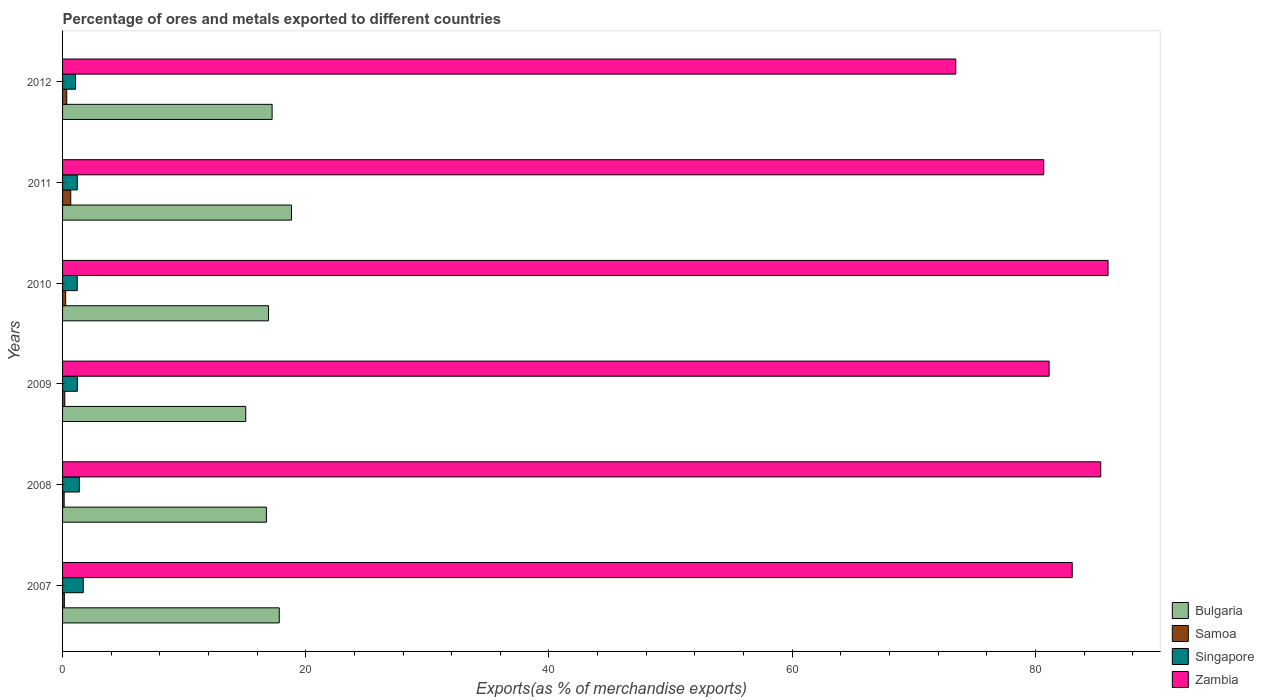How many different coloured bars are there?
Provide a succinct answer. 4. Are the number of bars on each tick of the Y-axis equal?
Keep it short and to the point. Yes. How many bars are there on the 4th tick from the bottom?
Provide a short and direct response. 4. What is the label of the 3rd group of bars from the top?
Your answer should be very brief. 2010. In how many cases, is the number of bars for a given year not equal to the number of legend labels?
Make the answer very short. 0. What is the percentage of exports to different countries in Bulgaria in 2011?
Give a very brief answer. 18.82. Across all years, what is the maximum percentage of exports to different countries in Samoa?
Offer a terse response. 0.67. Across all years, what is the minimum percentage of exports to different countries in Singapore?
Ensure brevity in your answer.  1.07. In which year was the percentage of exports to different countries in Zambia minimum?
Give a very brief answer. 2012. What is the total percentage of exports to different countries in Samoa in the graph?
Provide a short and direct response. 1.73. What is the difference between the percentage of exports to different countries in Singapore in 2008 and that in 2009?
Provide a succinct answer. 0.17. What is the difference between the percentage of exports to different countries in Singapore in 2008 and the percentage of exports to different countries in Zambia in 2007?
Your answer should be very brief. -81.65. What is the average percentage of exports to different countries in Singapore per year?
Provide a short and direct response. 1.3. In the year 2008, what is the difference between the percentage of exports to different countries in Samoa and percentage of exports to different countries in Bulgaria?
Make the answer very short. -16.63. What is the ratio of the percentage of exports to different countries in Bulgaria in 2007 to that in 2008?
Keep it short and to the point. 1.06. What is the difference between the highest and the second highest percentage of exports to different countries in Zambia?
Make the answer very short. 0.6. What is the difference between the highest and the lowest percentage of exports to different countries in Samoa?
Offer a very short reply. 0.54. Is the sum of the percentage of exports to different countries in Samoa in 2007 and 2010 greater than the maximum percentage of exports to different countries in Bulgaria across all years?
Make the answer very short. No. Is it the case that in every year, the sum of the percentage of exports to different countries in Singapore and percentage of exports to different countries in Zambia is greater than the sum of percentage of exports to different countries in Bulgaria and percentage of exports to different countries in Samoa?
Provide a succinct answer. Yes. What does the 2nd bar from the top in 2007 represents?
Provide a succinct answer. Singapore. Is it the case that in every year, the sum of the percentage of exports to different countries in Singapore and percentage of exports to different countries in Bulgaria is greater than the percentage of exports to different countries in Samoa?
Keep it short and to the point. Yes. How many years are there in the graph?
Your answer should be very brief. 6. Does the graph contain any zero values?
Provide a short and direct response. No. How many legend labels are there?
Offer a very short reply. 4. What is the title of the graph?
Offer a very short reply. Percentage of ores and metals exported to different countries. Does "Malta" appear as one of the legend labels in the graph?
Offer a very short reply. No. What is the label or title of the X-axis?
Your answer should be compact. Exports(as % of merchandise exports). What is the Exports(as % of merchandise exports) in Bulgaria in 2007?
Ensure brevity in your answer.  17.82. What is the Exports(as % of merchandise exports) of Samoa in 2007?
Make the answer very short. 0.15. What is the Exports(as % of merchandise exports) of Singapore in 2007?
Your answer should be compact. 1.7. What is the Exports(as % of merchandise exports) in Zambia in 2007?
Offer a terse response. 83.03. What is the Exports(as % of merchandise exports) of Bulgaria in 2008?
Offer a very short reply. 16.76. What is the Exports(as % of merchandise exports) in Samoa in 2008?
Ensure brevity in your answer.  0.13. What is the Exports(as % of merchandise exports) in Singapore in 2008?
Your answer should be very brief. 1.38. What is the Exports(as % of merchandise exports) of Zambia in 2008?
Ensure brevity in your answer.  85.37. What is the Exports(as % of merchandise exports) in Bulgaria in 2009?
Give a very brief answer. 15.06. What is the Exports(as % of merchandise exports) of Samoa in 2009?
Ensure brevity in your answer.  0.18. What is the Exports(as % of merchandise exports) of Singapore in 2009?
Provide a succinct answer. 1.22. What is the Exports(as % of merchandise exports) in Zambia in 2009?
Ensure brevity in your answer.  81.13. What is the Exports(as % of merchandise exports) of Bulgaria in 2010?
Keep it short and to the point. 16.93. What is the Exports(as % of merchandise exports) in Samoa in 2010?
Provide a short and direct response. 0.25. What is the Exports(as % of merchandise exports) in Singapore in 2010?
Ensure brevity in your answer.  1.21. What is the Exports(as % of merchandise exports) of Zambia in 2010?
Offer a terse response. 85.97. What is the Exports(as % of merchandise exports) in Bulgaria in 2011?
Offer a very short reply. 18.82. What is the Exports(as % of merchandise exports) in Samoa in 2011?
Offer a very short reply. 0.67. What is the Exports(as % of merchandise exports) in Singapore in 2011?
Provide a succinct answer. 1.21. What is the Exports(as % of merchandise exports) in Zambia in 2011?
Ensure brevity in your answer.  80.68. What is the Exports(as % of merchandise exports) of Bulgaria in 2012?
Your response must be concise. 17.23. What is the Exports(as % of merchandise exports) in Samoa in 2012?
Provide a succinct answer. 0.34. What is the Exports(as % of merchandise exports) in Singapore in 2012?
Your answer should be very brief. 1.07. What is the Exports(as % of merchandise exports) in Zambia in 2012?
Your answer should be compact. 73.45. Across all years, what is the maximum Exports(as % of merchandise exports) in Bulgaria?
Keep it short and to the point. 18.82. Across all years, what is the maximum Exports(as % of merchandise exports) of Samoa?
Your response must be concise. 0.67. Across all years, what is the maximum Exports(as % of merchandise exports) in Singapore?
Provide a succinct answer. 1.7. Across all years, what is the maximum Exports(as % of merchandise exports) in Zambia?
Provide a short and direct response. 85.97. Across all years, what is the minimum Exports(as % of merchandise exports) in Bulgaria?
Offer a terse response. 15.06. Across all years, what is the minimum Exports(as % of merchandise exports) in Samoa?
Your answer should be compact. 0.13. Across all years, what is the minimum Exports(as % of merchandise exports) of Singapore?
Provide a succinct answer. 1.07. Across all years, what is the minimum Exports(as % of merchandise exports) in Zambia?
Provide a short and direct response. 73.45. What is the total Exports(as % of merchandise exports) in Bulgaria in the graph?
Make the answer very short. 102.63. What is the total Exports(as % of merchandise exports) in Samoa in the graph?
Offer a terse response. 1.73. What is the total Exports(as % of merchandise exports) of Singapore in the graph?
Make the answer very short. 7.78. What is the total Exports(as % of merchandise exports) in Zambia in the graph?
Give a very brief answer. 489.63. What is the difference between the Exports(as % of merchandise exports) in Bulgaria in 2007 and that in 2008?
Your answer should be very brief. 1.06. What is the difference between the Exports(as % of merchandise exports) of Samoa in 2007 and that in 2008?
Offer a very short reply. 0.02. What is the difference between the Exports(as % of merchandise exports) of Singapore in 2007 and that in 2008?
Your answer should be very brief. 0.32. What is the difference between the Exports(as % of merchandise exports) in Zambia in 2007 and that in 2008?
Your response must be concise. -2.34. What is the difference between the Exports(as % of merchandise exports) in Bulgaria in 2007 and that in 2009?
Give a very brief answer. 2.76. What is the difference between the Exports(as % of merchandise exports) in Samoa in 2007 and that in 2009?
Your answer should be very brief. -0.04. What is the difference between the Exports(as % of merchandise exports) of Singapore in 2007 and that in 2009?
Ensure brevity in your answer.  0.48. What is the difference between the Exports(as % of merchandise exports) of Zambia in 2007 and that in 2009?
Your response must be concise. 1.9. What is the difference between the Exports(as % of merchandise exports) in Bulgaria in 2007 and that in 2010?
Provide a short and direct response. 0.88. What is the difference between the Exports(as % of merchandise exports) in Samoa in 2007 and that in 2010?
Give a very brief answer. -0.11. What is the difference between the Exports(as % of merchandise exports) in Singapore in 2007 and that in 2010?
Provide a succinct answer. 0.49. What is the difference between the Exports(as % of merchandise exports) in Zambia in 2007 and that in 2010?
Offer a very short reply. -2.95. What is the difference between the Exports(as % of merchandise exports) in Bulgaria in 2007 and that in 2011?
Offer a terse response. -1. What is the difference between the Exports(as % of merchandise exports) in Samoa in 2007 and that in 2011?
Your answer should be very brief. -0.53. What is the difference between the Exports(as % of merchandise exports) in Singapore in 2007 and that in 2011?
Your answer should be compact. 0.49. What is the difference between the Exports(as % of merchandise exports) in Zambia in 2007 and that in 2011?
Provide a short and direct response. 2.34. What is the difference between the Exports(as % of merchandise exports) of Bulgaria in 2007 and that in 2012?
Your answer should be compact. 0.59. What is the difference between the Exports(as % of merchandise exports) in Samoa in 2007 and that in 2012?
Your answer should be very brief. -0.19. What is the difference between the Exports(as % of merchandise exports) of Singapore in 2007 and that in 2012?
Keep it short and to the point. 0.63. What is the difference between the Exports(as % of merchandise exports) in Zambia in 2007 and that in 2012?
Offer a terse response. 9.58. What is the difference between the Exports(as % of merchandise exports) of Bulgaria in 2008 and that in 2009?
Make the answer very short. 1.7. What is the difference between the Exports(as % of merchandise exports) of Samoa in 2008 and that in 2009?
Keep it short and to the point. -0.05. What is the difference between the Exports(as % of merchandise exports) in Singapore in 2008 and that in 2009?
Offer a terse response. 0.17. What is the difference between the Exports(as % of merchandise exports) in Zambia in 2008 and that in 2009?
Keep it short and to the point. 4.25. What is the difference between the Exports(as % of merchandise exports) in Bulgaria in 2008 and that in 2010?
Keep it short and to the point. -0.17. What is the difference between the Exports(as % of merchandise exports) of Samoa in 2008 and that in 2010?
Provide a short and direct response. -0.12. What is the difference between the Exports(as % of merchandise exports) in Singapore in 2008 and that in 2010?
Offer a very short reply. 0.18. What is the difference between the Exports(as % of merchandise exports) in Zambia in 2008 and that in 2010?
Your answer should be compact. -0.6. What is the difference between the Exports(as % of merchandise exports) in Bulgaria in 2008 and that in 2011?
Make the answer very short. -2.06. What is the difference between the Exports(as % of merchandise exports) of Samoa in 2008 and that in 2011?
Give a very brief answer. -0.54. What is the difference between the Exports(as % of merchandise exports) of Singapore in 2008 and that in 2011?
Keep it short and to the point. 0.17. What is the difference between the Exports(as % of merchandise exports) of Zambia in 2008 and that in 2011?
Make the answer very short. 4.69. What is the difference between the Exports(as % of merchandise exports) of Bulgaria in 2008 and that in 2012?
Keep it short and to the point. -0.47. What is the difference between the Exports(as % of merchandise exports) in Samoa in 2008 and that in 2012?
Provide a succinct answer. -0.21. What is the difference between the Exports(as % of merchandise exports) of Singapore in 2008 and that in 2012?
Provide a short and direct response. 0.31. What is the difference between the Exports(as % of merchandise exports) in Zambia in 2008 and that in 2012?
Provide a succinct answer. 11.92. What is the difference between the Exports(as % of merchandise exports) in Bulgaria in 2009 and that in 2010?
Provide a succinct answer. -1.87. What is the difference between the Exports(as % of merchandise exports) of Samoa in 2009 and that in 2010?
Your answer should be compact. -0.07. What is the difference between the Exports(as % of merchandise exports) of Singapore in 2009 and that in 2010?
Your answer should be compact. 0.01. What is the difference between the Exports(as % of merchandise exports) in Zambia in 2009 and that in 2010?
Make the answer very short. -4.85. What is the difference between the Exports(as % of merchandise exports) of Bulgaria in 2009 and that in 2011?
Your answer should be compact. -3.76. What is the difference between the Exports(as % of merchandise exports) of Samoa in 2009 and that in 2011?
Provide a succinct answer. -0.49. What is the difference between the Exports(as % of merchandise exports) of Singapore in 2009 and that in 2011?
Provide a succinct answer. 0. What is the difference between the Exports(as % of merchandise exports) of Zambia in 2009 and that in 2011?
Ensure brevity in your answer.  0.44. What is the difference between the Exports(as % of merchandise exports) of Bulgaria in 2009 and that in 2012?
Your response must be concise. -2.17. What is the difference between the Exports(as % of merchandise exports) of Samoa in 2009 and that in 2012?
Offer a terse response. -0.16. What is the difference between the Exports(as % of merchandise exports) of Singapore in 2009 and that in 2012?
Offer a very short reply. 0.15. What is the difference between the Exports(as % of merchandise exports) of Zambia in 2009 and that in 2012?
Provide a short and direct response. 7.67. What is the difference between the Exports(as % of merchandise exports) in Bulgaria in 2010 and that in 2011?
Offer a terse response. -1.89. What is the difference between the Exports(as % of merchandise exports) in Samoa in 2010 and that in 2011?
Your response must be concise. -0.42. What is the difference between the Exports(as % of merchandise exports) in Singapore in 2010 and that in 2011?
Offer a very short reply. -0.01. What is the difference between the Exports(as % of merchandise exports) in Zambia in 2010 and that in 2011?
Your answer should be compact. 5.29. What is the difference between the Exports(as % of merchandise exports) in Bulgaria in 2010 and that in 2012?
Keep it short and to the point. -0.3. What is the difference between the Exports(as % of merchandise exports) of Samoa in 2010 and that in 2012?
Provide a succinct answer. -0.09. What is the difference between the Exports(as % of merchandise exports) of Singapore in 2010 and that in 2012?
Ensure brevity in your answer.  0.14. What is the difference between the Exports(as % of merchandise exports) in Zambia in 2010 and that in 2012?
Give a very brief answer. 12.52. What is the difference between the Exports(as % of merchandise exports) of Bulgaria in 2011 and that in 2012?
Offer a terse response. 1.59. What is the difference between the Exports(as % of merchandise exports) in Samoa in 2011 and that in 2012?
Your answer should be compact. 0.33. What is the difference between the Exports(as % of merchandise exports) in Singapore in 2011 and that in 2012?
Your answer should be very brief. 0.14. What is the difference between the Exports(as % of merchandise exports) of Zambia in 2011 and that in 2012?
Offer a very short reply. 7.23. What is the difference between the Exports(as % of merchandise exports) in Bulgaria in 2007 and the Exports(as % of merchandise exports) in Samoa in 2008?
Your response must be concise. 17.69. What is the difference between the Exports(as % of merchandise exports) of Bulgaria in 2007 and the Exports(as % of merchandise exports) of Singapore in 2008?
Make the answer very short. 16.44. What is the difference between the Exports(as % of merchandise exports) in Bulgaria in 2007 and the Exports(as % of merchandise exports) in Zambia in 2008?
Your answer should be very brief. -67.55. What is the difference between the Exports(as % of merchandise exports) of Samoa in 2007 and the Exports(as % of merchandise exports) of Singapore in 2008?
Give a very brief answer. -1.23. What is the difference between the Exports(as % of merchandise exports) of Samoa in 2007 and the Exports(as % of merchandise exports) of Zambia in 2008?
Provide a short and direct response. -85.22. What is the difference between the Exports(as % of merchandise exports) in Singapore in 2007 and the Exports(as % of merchandise exports) in Zambia in 2008?
Ensure brevity in your answer.  -83.67. What is the difference between the Exports(as % of merchandise exports) of Bulgaria in 2007 and the Exports(as % of merchandise exports) of Samoa in 2009?
Keep it short and to the point. 17.64. What is the difference between the Exports(as % of merchandise exports) of Bulgaria in 2007 and the Exports(as % of merchandise exports) of Singapore in 2009?
Provide a short and direct response. 16.6. What is the difference between the Exports(as % of merchandise exports) in Bulgaria in 2007 and the Exports(as % of merchandise exports) in Zambia in 2009?
Ensure brevity in your answer.  -63.31. What is the difference between the Exports(as % of merchandise exports) in Samoa in 2007 and the Exports(as % of merchandise exports) in Singapore in 2009?
Provide a succinct answer. -1.07. What is the difference between the Exports(as % of merchandise exports) in Samoa in 2007 and the Exports(as % of merchandise exports) in Zambia in 2009?
Keep it short and to the point. -80.98. What is the difference between the Exports(as % of merchandise exports) in Singapore in 2007 and the Exports(as % of merchandise exports) in Zambia in 2009?
Your answer should be compact. -79.43. What is the difference between the Exports(as % of merchandise exports) in Bulgaria in 2007 and the Exports(as % of merchandise exports) in Samoa in 2010?
Keep it short and to the point. 17.56. What is the difference between the Exports(as % of merchandise exports) of Bulgaria in 2007 and the Exports(as % of merchandise exports) of Singapore in 2010?
Provide a short and direct response. 16.61. What is the difference between the Exports(as % of merchandise exports) of Bulgaria in 2007 and the Exports(as % of merchandise exports) of Zambia in 2010?
Give a very brief answer. -68.15. What is the difference between the Exports(as % of merchandise exports) of Samoa in 2007 and the Exports(as % of merchandise exports) of Singapore in 2010?
Your answer should be very brief. -1.06. What is the difference between the Exports(as % of merchandise exports) in Samoa in 2007 and the Exports(as % of merchandise exports) in Zambia in 2010?
Offer a terse response. -85.83. What is the difference between the Exports(as % of merchandise exports) in Singapore in 2007 and the Exports(as % of merchandise exports) in Zambia in 2010?
Give a very brief answer. -84.27. What is the difference between the Exports(as % of merchandise exports) in Bulgaria in 2007 and the Exports(as % of merchandise exports) in Samoa in 2011?
Provide a succinct answer. 17.15. What is the difference between the Exports(as % of merchandise exports) in Bulgaria in 2007 and the Exports(as % of merchandise exports) in Singapore in 2011?
Provide a short and direct response. 16.61. What is the difference between the Exports(as % of merchandise exports) of Bulgaria in 2007 and the Exports(as % of merchandise exports) of Zambia in 2011?
Provide a short and direct response. -62.86. What is the difference between the Exports(as % of merchandise exports) of Samoa in 2007 and the Exports(as % of merchandise exports) of Singapore in 2011?
Your response must be concise. -1.06. What is the difference between the Exports(as % of merchandise exports) of Samoa in 2007 and the Exports(as % of merchandise exports) of Zambia in 2011?
Give a very brief answer. -80.54. What is the difference between the Exports(as % of merchandise exports) of Singapore in 2007 and the Exports(as % of merchandise exports) of Zambia in 2011?
Make the answer very short. -78.98. What is the difference between the Exports(as % of merchandise exports) in Bulgaria in 2007 and the Exports(as % of merchandise exports) in Samoa in 2012?
Provide a short and direct response. 17.48. What is the difference between the Exports(as % of merchandise exports) in Bulgaria in 2007 and the Exports(as % of merchandise exports) in Singapore in 2012?
Offer a very short reply. 16.75. What is the difference between the Exports(as % of merchandise exports) of Bulgaria in 2007 and the Exports(as % of merchandise exports) of Zambia in 2012?
Your answer should be very brief. -55.63. What is the difference between the Exports(as % of merchandise exports) in Samoa in 2007 and the Exports(as % of merchandise exports) in Singapore in 2012?
Give a very brief answer. -0.92. What is the difference between the Exports(as % of merchandise exports) in Samoa in 2007 and the Exports(as % of merchandise exports) in Zambia in 2012?
Offer a very short reply. -73.3. What is the difference between the Exports(as % of merchandise exports) in Singapore in 2007 and the Exports(as % of merchandise exports) in Zambia in 2012?
Provide a short and direct response. -71.75. What is the difference between the Exports(as % of merchandise exports) in Bulgaria in 2008 and the Exports(as % of merchandise exports) in Samoa in 2009?
Your answer should be compact. 16.58. What is the difference between the Exports(as % of merchandise exports) of Bulgaria in 2008 and the Exports(as % of merchandise exports) of Singapore in 2009?
Your answer should be very brief. 15.54. What is the difference between the Exports(as % of merchandise exports) in Bulgaria in 2008 and the Exports(as % of merchandise exports) in Zambia in 2009?
Keep it short and to the point. -64.37. What is the difference between the Exports(as % of merchandise exports) of Samoa in 2008 and the Exports(as % of merchandise exports) of Singapore in 2009?
Make the answer very short. -1.08. What is the difference between the Exports(as % of merchandise exports) of Samoa in 2008 and the Exports(as % of merchandise exports) of Zambia in 2009?
Provide a short and direct response. -81. What is the difference between the Exports(as % of merchandise exports) in Singapore in 2008 and the Exports(as % of merchandise exports) in Zambia in 2009?
Make the answer very short. -79.75. What is the difference between the Exports(as % of merchandise exports) in Bulgaria in 2008 and the Exports(as % of merchandise exports) in Samoa in 2010?
Your response must be concise. 16.51. What is the difference between the Exports(as % of merchandise exports) in Bulgaria in 2008 and the Exports(as % of merchandise exports) in Singapore in 2010?
Make the answer very short. 15.55. What is the difference between the Exports(as % of merchandise exports) in Bulgaria in 2008 and the Exports(as % of merchandise exports) in Zambia in 2010?
Ensure brevity in your answer.  -69.21. What is the difference between the Exports(as % of merchandise exports) of Samoa in 2008 and the Exports(as % of merchandise exports) of Singapore in 2010?
Your answer should be compact. -1.08. What is the difference between the Exports(as % of merchandise exports) of Samoa in 2008 and the Exports(as % of merchandise exports) of Zambia in 2010?
Your answer should be very brief. -85.84. What is the difference between the Exports(as % of merchandise exports) in Singapore in 2008 and the Exports(as % of merchandise exports) in Zambia in 2010?
Keep it short and to the point. -84.59. What is the difference between the Exports(as % of merchandise exports) of Bulgaria in 2008 and the Exports(as % of merchandise exports) of Samoa in 2011?
Ensure brevity in your answer.  16.09. What is the difference between the Exports(as % of merchandise exports) in Bulgaria in 2008 and the Exports(as % of merchandise exports) in Singapore in 2011?
Provide a short and direct response. 15.55. What is the difference between the Exports(as % of merchandise exports) of Bulgaria in 2008 and the Exports(as % of merchandise exports) of Zambia in 2011?
Provide a short and direct response. -63.92. What is the difference between the Exports(as % of merchandise exports) of Samoa in 2008 and the Exports(as % of merchandise exports) of Singapore in 2011?
Ensure brevity in your answer.  -1.08. What is the difference between the Exports(as % of merchandise exports) of Samoa in 2008 and the Exports(as % of merchandise exports) of Zambia in 2011?
Make the answer very short. -80.55. What is the difference between the Exports(as % of merchandise exports) in Singapore in 2008 and the Exports(as % of merchandise exports) in Zambia in 2011?
Ensure brevity in your answer.  -79.3. What is the difference between the Exports(as % of merchandise exports) in Bulgaria in 2008 and the Exports(as % of merchandise exports) in Samoa in 2012?
Offer a terse response. 16.42. What is the difference between the Exports(as % of merchandise exports) in Bulgaria in 2008 and the Exports(as % of merchandise exports) in Singapore in 2012?
Keep it short and to the point. 15.69. What is the difference between the Exports(as % of merchandise exports) of Bulgaria in 2008 and the Exports(as % of merchandise exports) of Zambia in 2012?
Offer a terse response. -56.69. What is the difference between the Exports(as % of merchandise exports) in Samoa in 2008 and the Exports(as % of merchandise exports) in Singapore in 2012?
Provide a succinct answer. -0.94. What is the difference between the Exports(as % of merchandise exports) in Samoa in 2008 and the Exports(as % of merchandise exports) in Zambia in 2012?
Keep it short and to the point. -73.32. What is the difference between the Exports(as % of merchandise exports) in Singapore in 2008 and the Exports(as % of merchandise exports) in Zambia in 2012?
Your response must be concise. -72.07. What is the difference between the Exports(as % of merchandise exports) in Bulgaria in 2009 and the Exports(as % of merchandise exports) in Samoa in 2010?
Provide a succinct answer. 14.81. What is the difference between the Exports(as % of merchandise exports) of Bulgaria in 2009 and the Exports(as % of merchandise exports) of Singapore in 2010?
Your answer should be compact. 13.86. What is the difference between the Exports(as % of merchandise exports) in Bulgaria in 2009 and the Exports(as % of merchandise exports) in Zambia in 2010?
Keep it short and to the point. -70.91. What is the difference between the Exports(as % of merchandise exports) in Samoa in 2009 and the Exports(as % of merchandise exports) in Singapore in 2010?
Your answer should be compact. -1.02. What is the difference between the Exports(as % of merchandise exports) of Samoa in 2009 and the Exports(as % of merchandise exports) of Zambia in 2010?
Provide a short and direct response. -85.79. What is the difference between the Exports(as % of merchandise exports) of Singapore in 2009 and the Exports(as % of merchandise exports) of Zambia in 2010?
Offer a terse response. -84.76. What is the difference between the Exports(as % of merchandise exports) in Bulgaria in 2009 and the Exports(as % of merchandise exports) in Samoa in 2011?
Your answer should be compact. 14.39. What is the difference between the Exports(as % of merchandise exports) of Bulgaria in 2009 and the Exports(as % of merchandise exports) of Singapore in 2011?
Give a very brief answer. 13.85. What is the difference between the Exports(as % of merchandise exports) in Bulgaria in 2009 and the Exports(as % of merchandise exports) in Zambia in 2011?
Your answer should be compact. -65.62. What is the difference between the Exports(as % of merchandise exports) of Samoa in 2009 and the Exports(as % of merchandise exports) of Singapore in 2011?
Give a very brief answer. -1.03. What is the difference between the Exports(as % of merchandise exports) of Samoa in 2009 and the Exports(as % of merchandise exports) of Zambia in 2011?
Your answer should be compact. -80.5. What is the difference between the Exports(as % of merchandise exports) in Singapore in 2009 and the Exports(as % of merchandise exports) in Zambia in 2011?
Offer a terse response. -79.47. What is the difference between the Exports(as % of merchandise exports) of Bulgaria in 2009 and the Exports(as % of merchandise exports) of Samoa in 2012?
Offer a very short reply. 14.72. What is the difference between the Exports(as % of merchandise exports) of Bulgaria in 2009 and the Exports(as % of merchandise exports) of Singapore in 2012?
Offer a very short reply. 13.99. What is the difference between the Exports(as % of merchandise exports) of Bulgaria in 2009 and the Exports(as % of merchandise exports) of Zambia in 2012?
Offer a very short reply. -58.39. What is the difference between the Exports(as % of merchandise exports) of Samoa in 2009 and the Exports(as % of merchandise exports) of Singapore in 2012?
Make the answer very short. -0.88. What is the difference between the Exports(as % of merchandise exports) of Samoa in 2009 and the Exports(as % of merchandise exports) of Zambia in 2012?
Keep it short and to the point. -73.27. What is the difference between the Exports(as % of merchandise exports) in Singapore in 2009 and the Exports(as % of merchandise exports) in Zambia in 2012?
Your answer should be very brief. -72.24. What is the difference between the Exports(as % of merchandise exports) in Bulgaria in 2010 and the Exports(as % of merchandise exports) in Samoa in 2011?
Provide a short and direct response. 16.26. What is the difference between the Exports(as % of merchandise exports) of Bulgaria in 2010 and the Exports(as % of merchandise exports) of Singapore in 2011?
Offer a very short reply. 15.72. What is the difference between the Exports(as % of merchandise exports) of Bulgaria in 2010 and the Exports(as % of merchandise exports) of Zambia in 2011?
Your answer should be compact. -63.75. What is the difference between the Exports(as % of merchandise exports) in Samoa in 2010 and the Exports(as % of merchandise exports) in Singapore in 2011?
Offer a very short reply. -0.96. What is the difference between the Exports(as % of merchandise exports) in Samoa in 2010 and the Exports(as % of merchandise exports) in Zambia in 2011?
Make the answer very short. -80.43. What is the difference between the Exports(as % of merchandise exports) of Singapore in 2010 and the Exports(as % of merchandise exports) of Zambia in 2011?
Keep it short and to the point. -79.48. What is the difference between the Exports(as % of merchandise exports) of Bulgaria in 2010 and the Exports(as % of merchandise exports) of Samoa in 2012?
Your answer should be compact. 16.59. What is the difference between the Exports(as % of merchandise exports) of Bulgaria in 2010 and the Exports(as % of merchandise exports) of Singapore in 2012?
Keep it short and to the point. 15.87. What is the difference between the Exports(as % of merchandise exports) of Bulgaria in 2010 and the Exports(as % of merchandise exports) of Zambia in 2012?
Offer a very short reply. -56.52. What is the difference between the Exports(as % of merchandise exports) of Samoa in 2010 and the Exports(as % of merchandise exports) of Singapore in 2012?
Keep it short and to the point. -0.81. What is the difference between the Exports(as % of merchandise exports) of Samoa in 2010 and the Exports(as % of merchandise exports) of Zambia in 2012?
Offer a very short reply. -73.2. What is the difference between the Exports(as % of merchandise exports) of Singapore in 2010 and the Exports(as % of merchandise exports) of Zambia in 2012?
Offer a very short reply. -72.25. What is the difference between the Exports(as % of merchandise exports) in Bulgaria in 2011 and the Exports(as % of merchandise exports) in Samoa in 2012?
Provide a short and direct response. 18.48. What is the difference between the Exports(as % of merchandise exports) of Bulgaria in 2011 and the Exports(as % of merchandise exports) of Singapore in 2012?
Make the answer very short. 17.75. What is the difference between the Exports(as % of merchandise exports) in Bulgaria in 2011 and the Exports(as % of merchandise exports) in Zambia in 2012?
Your response must be concise. -54.63. What is the difference between the Exports(as % of merchandise exports) of Samoa in 2011 and the Exports(as % of merchandise exports) of Singapore in 2012?
Keep it short and to the point. -0.39. What is the difference between the Exports(as % of merchandise exports) in Samoa in 2011 and the Exports(as % of merchandise exports) in Zambia in 2012?
Provide a succinct answer. -72.78. What is the difference between the Exports(as % of merchandise exports) of Singapore in 2011 and the Exports(as % of merchandise exports) of Zambia in 2012?
Your answer should be compact. -72.24. What is the average Exports(as % of merchandise exports) in Bulgaria per year?
Offer a terse response. 17.11. What is the average Exports(as % of merchandise exports) of Samoa per year?
Give a very brief answer. 0.29. What is the average Exports(as % of merchandise exports) of Singapore per year?
Offer a very short reply. 1.3. What is the average Exports(as % of merchandise exports) of Zambia per year?
Your answer should be very brief. 81.61. In the year 2007, what is the difference between the Exports(as % of merchandise exports) in Bulgaria and Exports(as % of merchandise exports) in Samoa?
Your answer should be very brief. 17.67. In the year 2007, what is the difference between the Exports(as % of merchandise exports) in Bulgaria and Exports(as % of merchandise exports) in Singapore?
Your answer should be compact. 16.12. In the year 2007, what is the difference between the Exports(as % of merchandise exports) of Bulgaria and Exports(as % of merchandise exports) of Zambia?
Your answer should be very brief. -65.21. In the year 2007, what is the difference between the Exports(as % of merchandise exports) of Samoa and Exports(as % of merchandise exports) of Singapore?
Your answer should be very brief. -1.55. In the year 2007, what is the difference between the Exports(as % of merchandise exports) in Samoa and Exports(as % of merchandise exports) in Zambia?
Make the answer very short. -82.88. In the year 2007, what is the difference between the Exports(as % of merchandise exports) in Singapore and Exports(as % of merchandise exports) in Zambia?
Your response must be concise. -81.33. In the year 2008, what is the difference between the Exports(as % of merchandise exports) of Bulgaria and Exports(as % of merchandise exports) of Samoa?
Make the answer very short. 16.63. In the year 2008, what is the difference between the Exports(as % of merchandise exports) of Bulgaria and Exports(as % of merchandise exports) of Singapore?
Make the answer very short. 15.38. In the year 2008, what is the difference between the Exports(as % of merchandise exports) in Bulgaria and Exports(as % of merchandise exports) in Zambia?
Provide a short and direct response. -68.61. In the year 2008, what is the difference between the Exports(as % of merchandise exports) in Samoa and Exports(as % of merchandise exports) in Singapore?
Your answer should be very brief. -1.25. In the year 2008, what is the difference between the Exports(as % of merchandise exports) in Samoa and Exports(as % of merchandise exports) in Zambia?
Ensure brevity in your answer.  -85.24. In the year 2008, what is the difference between the Exports(as % of merchandise exports) in Singapore and Exports(as % of merchandise exports) in Zambia?
Make the answer very short. -83.99. In the year 2009, what is the difference between the Exports(as % of merchandise exports) of Bulgaria and Exports(as % of merchandise exports) of Samoa?
Make the answer very short. 14.88. In the year 2009, what is the difference between the Exports(as % of merchandise exports) in Bulgaria and Exports(as % of merchandise exports) in Singapore?
Offer a terse response. 13.85. In the year 2009, what is the difference between the Exports(as % of merchandise exports) in Bulgaria and Exports(as % of merchandise exports) in Zambia?
Make the answer very short. -66.06. In the year 2009, what is the difference between the Exports(as % of merchandise exports) of Samoa and Exports(as % of merchandise exports) of Singapore?
Offer a very short reply. -1.03. In the year 2009, what is the difference between the Exports(as % of merchandise exports) in Samoa and Exports(as % of merchandise exports) in Zambia?
Your answer should be compact. -80.94. In the year 2009, what is the difference between the Exports(as % of merchandise exports) of Singapore and Exports(as % of merchandise exports) of Zambia?
Your response must be concise. -79.91. In the year 2010, what is the difference between the Exports(as % of merchandise exports) of Bulgaria and Exports(as % of merchandise exports) of Samoa?
Provide a succinct answer. 16.68. In the year 2010, what is the difference between the Exports(as % of merchandise exports) in Bulgaria and Exports(as % of merchandise exports) in Singapore?
Offer a very short reply. 15.73. In the year 2010, what is the difference between the Exports(as % of merchandise exports) in Bulgaria and Exports(as % of merchandise exports) in Zambia?
Provide a succinct answer. -69.04. In the year 2010, what is the difference between the Exports(as % of merchandise exports) of Samoa and Exports(as % of merchandise exports) of Singapore?
Offer a terse response. -0.95. In the year 2010, what is the difference between the Exports(as % of merchandise exports) of Samoa and Exports(as % of merchandise exports) of Zambia?
Make the answer very short. -85.72. In the year 2010, what is the difference between the Exports(as % of merchandise exports) in Singapore and Exports(as % of merchandise exports) in Zambia?
Offer a very short reply. -84.77. In the year 2011, what is the difference between the Exports(as % of merchandise exports) of Bulgaria and Exports(as % of merchandise exports) of Samoa?
Offer a terse response. 18.15. In the year 2011, what is the difference between the Exports(as % of merchandise exports) in Bulgaria and Exports(as % of merchandise exports) in Singapore?
Your answer should be very brief. 17.61. In the year 2011, what is the difference between the Exports(as % of merchandise exports) of Bulgaria and Exports(as % of merchandise exports) of Zambia?
Provide a short and direct response. -61.86. In the year 2011, what is the difference between the Exports(as % of merchandise exports) in Samoa and Exports(as % of merchandise exports) in Singapore?
Your response must be concise. -0.54. In the year 2011, what is the difference between the Exports(as % of merchandise exports) in Samoa and Exports(as % of merchandise exports) in Zambia?
Your answer should be very brief. -80.01. In the year 2011, what is the difference between the Exports(as % of merchandise exports) in Singapore and Exports(as % of merchandise exports) in Zambia?
Ensure brevity in your answer.  -79.47. In the year 2012, what is the difference between the Exports(as % of merchandise exports) in Bulgaria and Exports(as % of merchandise exports) in Samoa?
Your response must be concise. 16.89. In the year 2012, what is the difference between the Exports(as % of merchandise exports) of Bulgaria and Exports(as % of merchandise exports) of Singapore?
Your answer should be very brief. 16.16. In the year 2012, what is the difference between the Exports(as % of merchandise exports) of Bulgaria and Exports(as % of merchandise exports) of Zambia?
Your answer should be very brief. -56.22. In the year 2012, what is the difference between the Exports(as % of merchandise exports) of Samoa and Exports(as % of merchandise exports) of Singapore?
Make the answer very short. -0.73. In the year 2012, what is the difference between the Exports(as % of merchandise exports) of Samoa and Exports(as % of merchandise exports) of Zambia?
Your answer should be very brief. -73.11. In the year 2012, what is the difference between the Exports(as % of merchandise exports) in Singapore and Exports(as % of merchandise exports) in Zambia?
Your answer should be compact. -72.38. What is the ratio of the Exports(as % of merchandise exports) of Bulgaria in 2007 to that in 2008?
Your answer should be very brief. 1.06. What is the ratio of the Exports(as % of merchandise exports) in Samoa in 2007 to that in 2008?
Offer a very short reply. 1.13. What is the ratio of the Exports(as % of merchandise exports) in Singapore in 2007 to that in 2008?
Your response must be concise. 1.23. What is the ratio of the Exports(as % of merchandise exports) in Zambia in 2007 to that in 2008?
Keep it short and to the point. 0.97. What is the ratio of the Exports(as % of merchandise exports) of Bulgaria in 2007 to that in 2009?
Your answer should be very brief. 1.18. What is the ratio of the Exports(as % of merchandise exports) of Samoa in 2007 to that in 2009?
Offer a terse response. 0.81. What is the ratio of the Exports(as % of merchandise exports) in Singapore in 2007 to that in 2009?
Provide a short and direct response. 1.4. What is the ratio of the Exports(as % of merchandise exports) of Zambia in 2007 to that in 2009?
Your response must be concise. 1.02. What is the ratio of the Exports(as % of merchandise exports) in Bulgaria in 2007 to that in 2010?
Offer a very short reply. 1.05. What is the ratio of the Exports(as % of merchandise exports) of Samoa in 2007 to that in 2010?
Keep it short and to the point. 0.58. What is the ratio of the Exports(as % of merchandise exports) of Singapore in 2007 to that in 2010?
Provide a succinct answer. 1.41. What is the ratio of the Exports(as % of merchandise exports) of Zambia in 2007 to that in 2010?
Ensure brevity in your answer.  0.97. What is the ratio of the Exports(as % of merchandise exports) of Bulgaria in 2007 to that in 2011?
Keep it short and to the point. 0.95. What is the ratio of the Exports(as % of merchandise exports) of Samoa in 2007 to that in 2011?
Ensure brevity in your answer.  0.22. What is the ratio of the Exports(as % of merchandise exports) of Singapore in 2007 to that in 2011?
Ensure brevity in your answer.  1.4. What is the ratio of the Exports(as % of merchandise exports) in Zambia in 2007 to that in 2011?
Give a very brief answer. 1.03. What is the ratio of the Exports(as % of merchandise exports) in Bulgaria in 2007 to that in 2012?
Make the answer very short. 1.03. What is the ratio of the Exports(as % of merchandise exports) of Samoa in 2007 to that in 2012?
Provide a short and direct response. 0.43. What is the ratio of the Exports(as % of merchandise exports) in Singapore in 2007 to that in 2012?
Provide a succinct answer. 1.59. What is the ratio of the Exports(as % of merchandise exports) in Zambia in 2007 to that in 2012?
Make the answer very short. 1.13. What is the ratio of the Exports(as % of merchandise exports) of Bulgaria in 2008 to that in 2009?
Your answer should be compact. 1.11. What is the ratio of the Exports(as % of merchandise exports) in Samoa in 2008 to that in 2009?
Make the answer very short. 0.71. What is the ratio of the Exports(as % of merchandise exports) of Singapore in 2008 to that in 2009?
Give a very brief answer. 1.14. What is the ratio of the Exports(as % of merchandise exports) of Zambia in 2008 to that in 2009?
Ensure brevity in your answer.  1.05. What is the ratio of the Exports(as % of merchandise exports) in Bulgaria in 2008 to that in 2010?
Your answer should be compact. 0.99. What is the ratio of the Exports(as % of merchandise exports) in Samoa in 2008 to that in 2010?
Provide a short and direct response. 0.51. What is the ratio of the Exports(as % of merchandise exports) of Singapore in 2008 to that in 2010?
Provide a short and direct response. 1.15. What is the ratio of the Exports(as % of merchandise exports) in Bulgaria in 2008 to that in 2011?
Offer a terse response. 0.89. What is the ratio of the Exports(as % of merchandise exports) of Samoa in 2008 to that in 2011?
Make the answer very short. 0.19. What is the ratio of the Exports(as % of merchandise exports) in Singapore in 2008 to that in 2011?
Your answer should be compact. 1.14. What is the ratio of the Exports(as % of merchandise exports) in Zambia in 2008 to that in 2011?
Offer a very short reply. 1.06. What is the ratio of the Exports(as % of merchandise exports) in Bulgaria in 2008 to that in 2012?
Make the answer very short. 0.97. What is the ratio of the Exports(as % of merchandise exports) of Samoa in 2008 to that in 2012?
Make the answer very short. 0.38. What is the ratio of the Exports(as % of merchandise exports) of Singapore in 2008 to that in 2012?
Keep it short and to the point. 1.29. What is the ratio of the Exports(as % of merchandise exports) in Zambia in 2008 to that in 2012?
Ensure brevity in your answer.  1.16. What is the ratio of the Exports(as % of merchandise exports) of Bulgaria in 2009 to that in 2010?
Ensure brevity in your answer.  0.89. What is the ratio of the Exports(as % of merchandise exports) in Samoa in 2009 to that in 2010?
Provide a succinct answer. 0.72. What is the ratio of the Exports(as % of merchandise exports) in Singapore in 2009 to that in 2010?
Your response must be concise. 1.01. What is the ratio of the Exports(as % of merchandise exports) of Zambia in 2009 to that in 2010?
Offer a very short reply. 0.94. What is the ratio of the Exports(as % of merchandise exports) in Bulgaria in 2009 to that in 2011?
Provide a succinct answer. 0.8. What is the ratio of the Exports(as % of merchandise exports) of Samoa in 2009 to that in 2011?
Offer a terse response. 0.27. What is the ratio of the Exports(as % of merchandise exports) of Singapore in 2009 to that in 2011?
Offer a terse response. 1. What is the ratio of the Exports(as % of merchandise exports) of Zambia in 2009 to that in 2011?
Ensure brevity in your answer.  1.01. What is the ratio of the Exports(as % of merchandise exports) in Bulgaria in 2009 to that in 2012?
Offer a terse response. 0.87. What is the ratio of the Exports(as % of merchandise exports) in Samoa in 2009 to that in 2012?
Offer a terse response. 0.54. What is the ratio of the Exports(as % of merchandise exports) of Singapore in 2009 to that in 2012?
Give a very brief answer. 1.14. What is the ratio of the Exports(as % of merchandise exports) of Zambia in 2009 to that in 2012?
Keep it short and to the point. 1.1. What is the ratio of the Exports(as % of merchandise exports) of Bulgaria in 2010 to that in 2011?
Your answer should be very brief. 0.9. What is the ratio of the Exports(as % of merchandise exports) of Samoa in 2010 to that in 2011?
Offer a terse response. 0.38. What is the ratio of the Exports(as % of merchandise exports) of Zambia in 2010 to that in 2011?
Your answer should be very brief. 1.07. What is the ratio of the Exports(as % of merchandise exports) in Bulgaria in 2010 to that in 2012?
Provide a succinct answer. 0.98. What is the ratio of the Exports(as % of merchandise exports) in Samoa in 2010 to that in 2012?
Provide a succinct answer. 0.74. What is the ratio of the Exports(as % of merchandise exports) of Singapore in 2010 to that in 2012?
Provide a succinct answer. 1.13. What is the ratio of the Exports(as % of merchandise exports) of Zambia in 2010 to that in 2012?
Offer a terse response. 1.17. What is the ratio of the Exports(as % of merchandise exports) of Bulgaria in 2011 to that in 2012?
Provide a short and direct response. 1.09. What is the ratio of the Exports(as % of merchandise exports) of Samoa in 2011 to that in 2012?
Provide a short and direct response. 1.97. What is the ratio of the Exports(as % of merchandise exports) of Singapore in 2011 to that in 2012?
Your response must be concise. 1.13. What is the ratio of the Exports(as % of merchandise exports) of Zambia in 2011 to that in 2012?
Your answer should be compact. 1.1. What is the difference between the highest and the second highest Exports(as % of merchandise exports) in Samoa?
Ensure brevity in your answer.  0.33. What is the difference between the highest and the second highest Exports(as % of merchandise exports) of Singapore?
Ensure brevity in your answer.  0.32. What is the difference between the highest and the second highest Exports(as % of merchandise exports) of Zambia?
Provide a succinct answer. 0.6. What is the difference between the highest and the lowest Exports(as % of merchandise exports) in Bulgaria?
Provide a succinct answer. 3.76. What is the difference between the highest and the lowest Exports(as % of merchandise exports) of Samoa?
Your answer should be very brief. 0.54. What is the difference between the highest and the lowest Exports(as % of merchandise exports) in Singapore?
Make the answer very short. 0.63. What is the difference between the highest and the lowest Exports(as % of merchandise exports) of Zambia?
Make the answer very short. 12.52. 